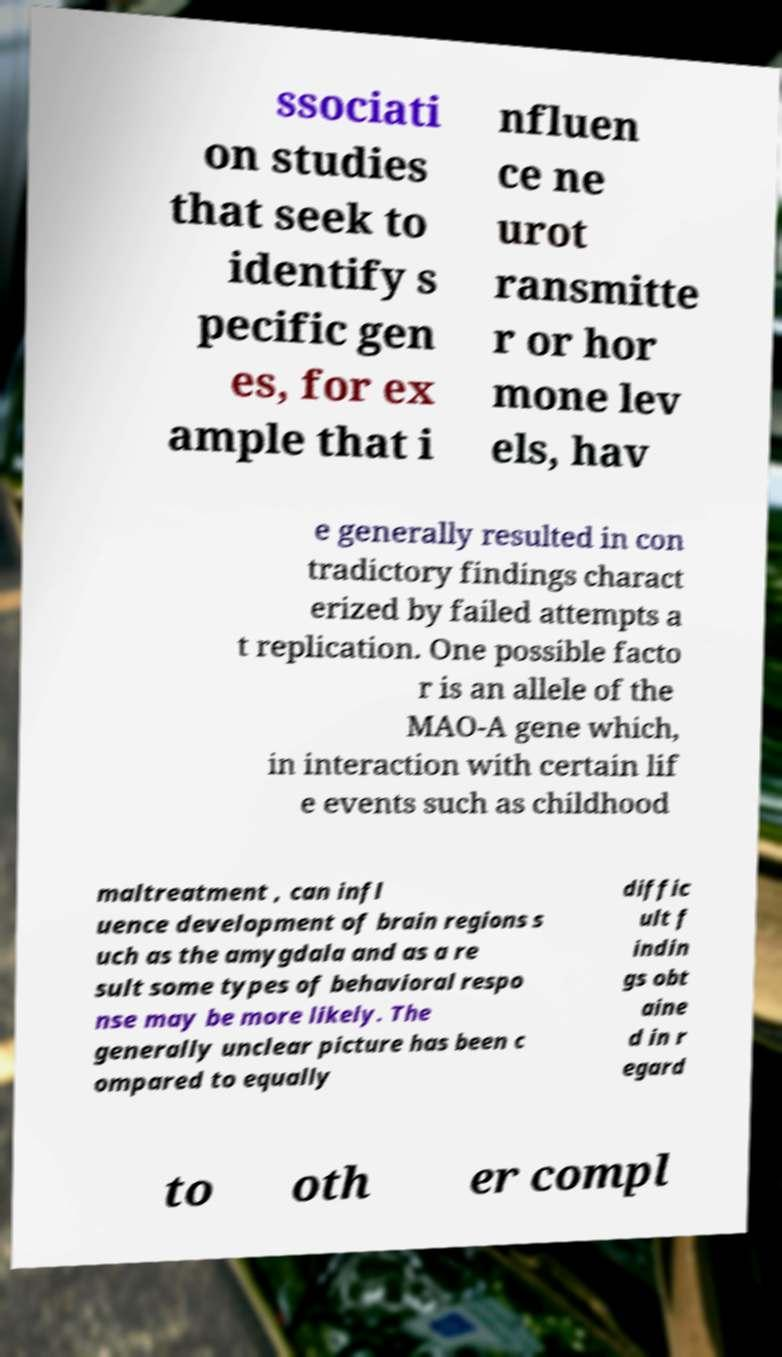Please identify and transcribe the text found in this image. ssociati on studies that seek to identify s pecific gen es, for ex ample that i nfluen ce ne urot ransmitte r or hor mone lev els, hav e generally resulted in con tradictory findings charact erized by failed attempts a t replication. One possible facto r is an allele of the MAO-A gene which, in interaction with certain lif e events such as childhood maltreatment , can infl uence development of brain regions s uch as the amygdala and as a re sult some types of behavioral respo nse may be more likely. The generally unclear picture has been c ompared to equally diffic ult f indin gs obt aine d in r egard to oth er compl 